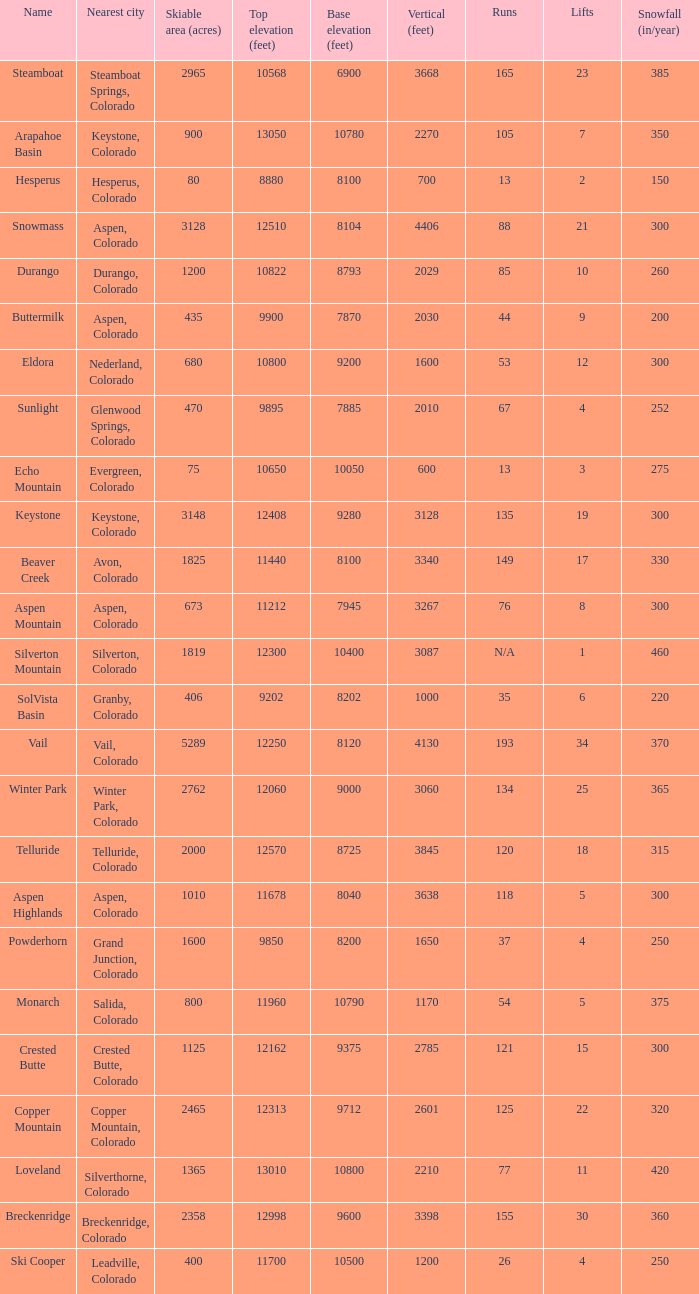If the name is Steamboat, what is the top elevation? 10568.0. 